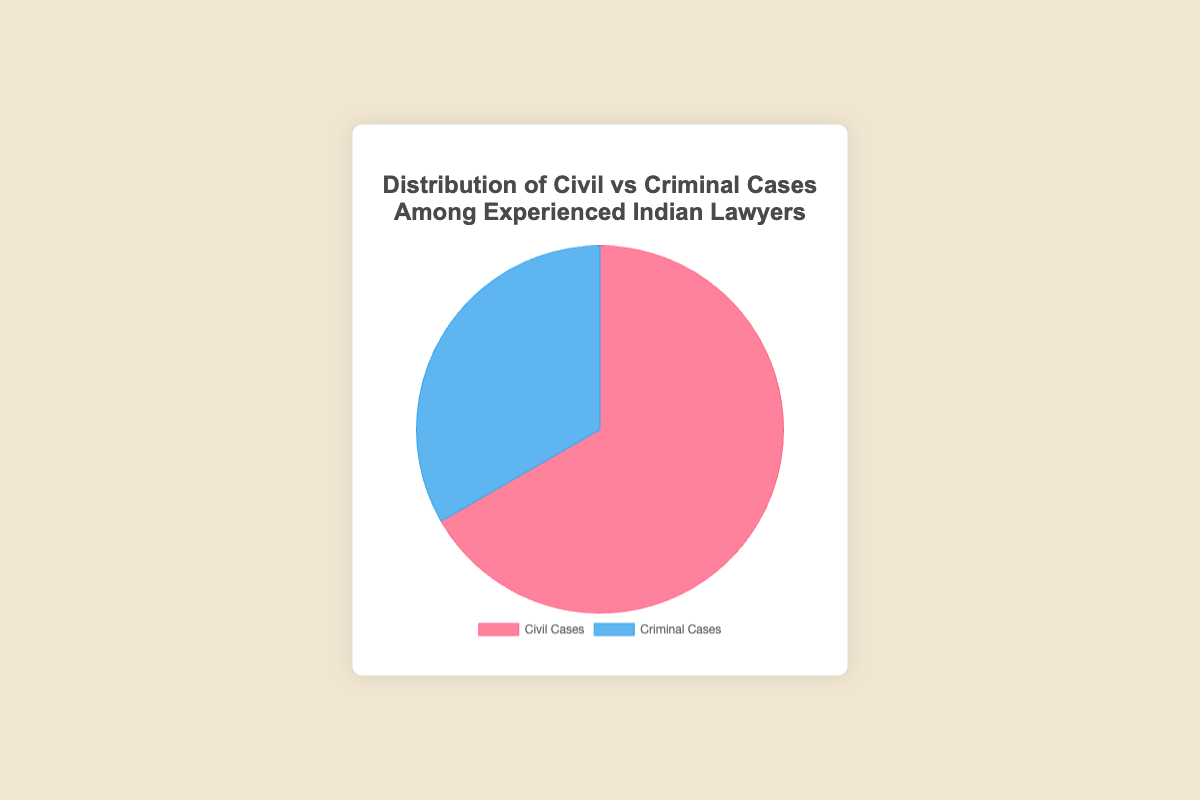What is the total number of cases handled by Rajesh Kumar? Rajesh Kumar handled 150 civil cases and 90 criminal cases. The total number of cases is 150 + 90.
Answer: 240 What is the percentage of civil cases among the cases handled by Lakshmi Nair? Lakshmi Nair handled 160 civil cases and 110 criminal cases. The total number of cases is 160 + 110 = 270. The percentage of civil cases is (160 / 270) * 100.
Answer: 59.3% How many more civil cases than criminal cases were handled by Mukesh Gupta? Mukesh Gupta handled 180 civil cases and 70 criminal cases. The difference is 180 - 70.
Answer: 110 Which lawyer handled the most criminal cases? Comparing the criminal cases handled by all lawyers: Rajesh Kumar (90), Anita Sharma (100), Mukesh Gupta (70), Lakshmi Nair (110), Suresh Menon (80). The highest number is 110, handled by Lakshmi Nair.
Answer: Lakshmi Nair By how much do civil cases outnumber criminal cases in total? Total civil cases are 900. Total criminal cases are 450. The difference is 900 - 450.
Answer: 450 What is the ratio of civil cases to criminal cases for Suresh Menon? Suresh Menon handled 210 civil cases and 80 criminal cases. The ratio is 210:80.
Answer: 21:8 What is the average number of civil cases handled by the lawyers? Total civil cases are 900 and there are 5 lawyers. The average is 900 / 5.
Answer: 180 Which category of cases (civil or criminal) is represented with the blue color in the pie chart? The pie chart visualizes civil cases in red and criminal cases in blue, as per the description of the color scheme used.
Answer: Criminal cases What is the proportion of criminal cases handled by all the lawyers together? Total criminal cases are 450 and total cases are 1350. The proportion is 450 / 1350.
Answer: 1/3 or approximately 33.3% Which lawyer has handled the fewest cases in total? Comparing total cases handled by all lawyers: Rajesh Kumar (240), Anita Sharma (300), Mukesh Gupta (250), Lakshmi Nair (270), Suresh Menon (290). The lowest number is 240, handled by Rajesh Kumar.
Answer: Rajesh Kumar 